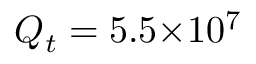Convert formula to latex. <formula><loc_0><loc_0><loc_500><loc_500>Q _ { t } = 5 . 5 { \times } 1 0 ^ { 7 }</formula> 